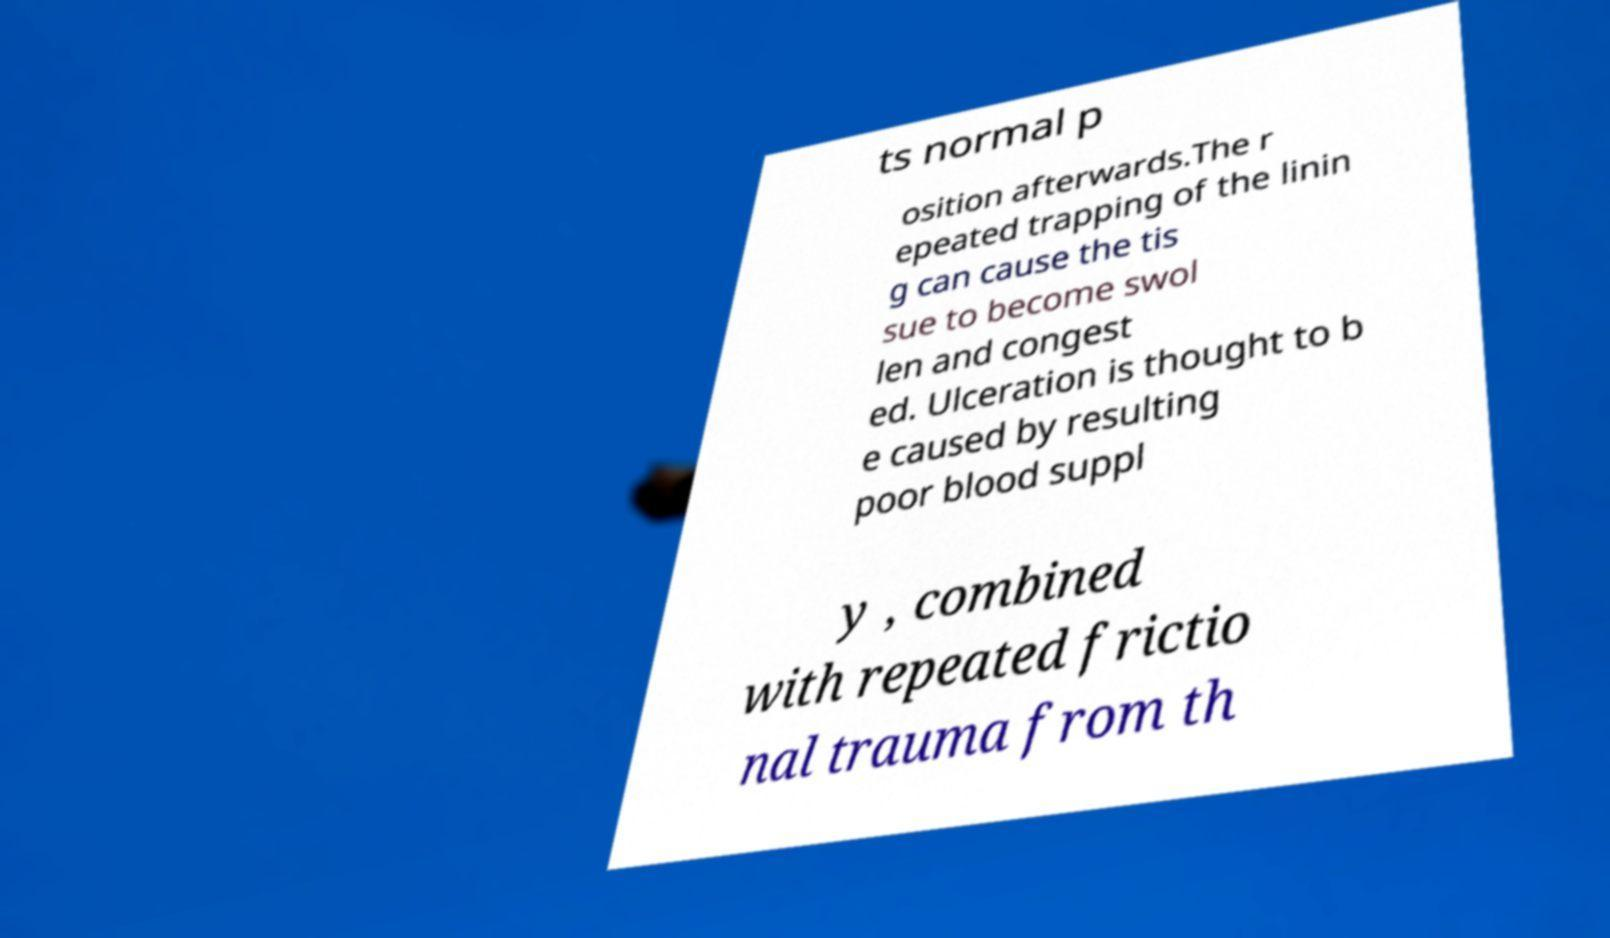For documentation purposes, I need the text within this image transcribed. Could you provide that? ts normal p osition afterwards.The r epeated trapping of the linin g can cause the tis sue to become swol len and congest ed. Ulceration is thought to b e caused by resulting poor blood suppl y , combined with repeated frictio nal trauma from th 